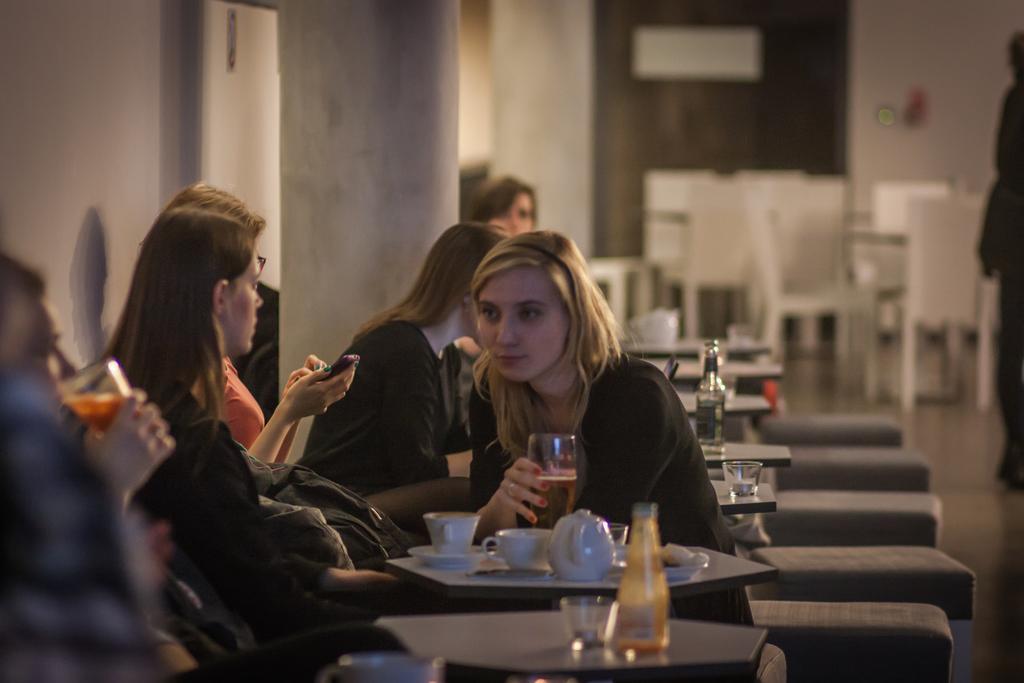Please provide a concise description of this image. In this picture we can see some girls sitting here, there are some tables here, we can see a kettle, two cups and saucers on this table, in the background there are some chairs, we can see a wall here, a girl on the left side is holding a glass. 